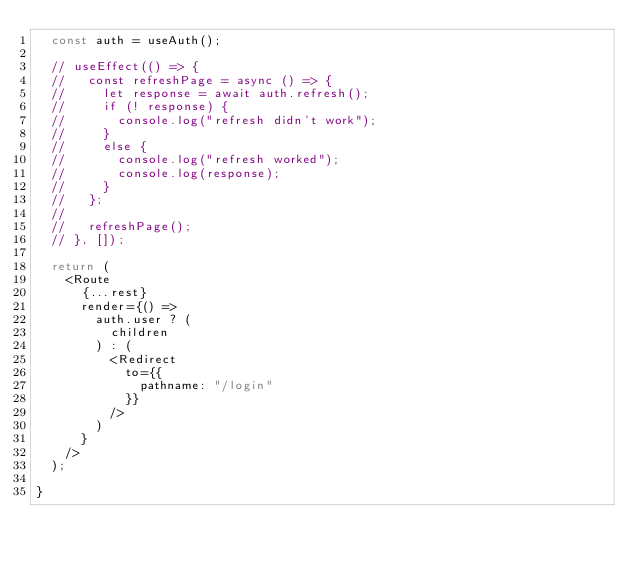<code> <loc_0><loc_0><loc_500><loc_500><_JavaScript_>  const auth = useAuth();

  // useEffect(() => {
  //   const refreshPage = async () => {
  //     let response = await auth.refresh();
  //     if (! response) {
  //       console.log("refresh didn't work");
  //     }
  //     else {
  //       console.log("refresh worked");
  //       console.log(response);
  //     }
  //   };
  //
  //   refreshPage();
  // }, []);

  return (
    <Route
      {...rest}
      render={() =>
        auth.user ? (
          children
        ) : (
          <Redirect
            to={{
              pathname: "/login"
            }}
          />
        )
      }
    />
  );

}
</code> 